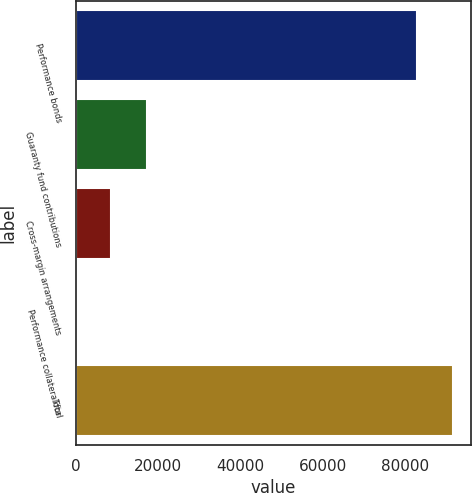Convert chart. <chart><loc_0><loc_0><loc_500><loc_500><bar_chart><fcel>Performance bonds<fcel>Guaranty fund contributions<fcel>Cross-margin arrangements<fcel>Performance collateral for<fcel>Total<nl><fcel>82867.7<fcel>17180.7<fcel>8591.38<fcel>2.1<fcel>91457<nl></chart> 